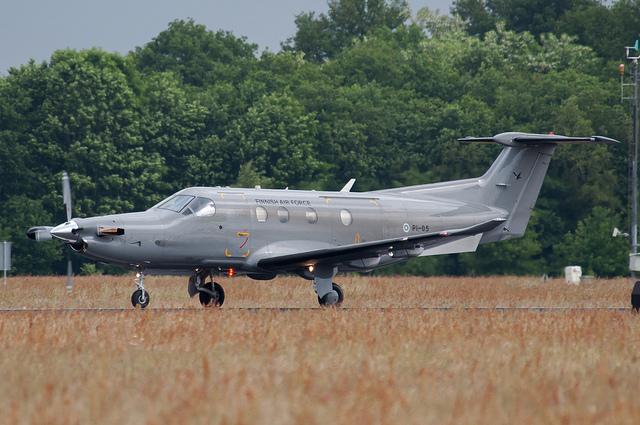Is this an airport?
Write a very short answer. Yes. Is this a jet?
Quick response, please. Yes. Is the plane departing?
Be succinct. Yes. What is in motion?
Write a very short answer. Plane. What colors does the plane have?
Be succinct. Gray. What is the plane doing?
Concise answer only. Landing. What kind of trees are in the background?
Write a very short answer. Oak. 